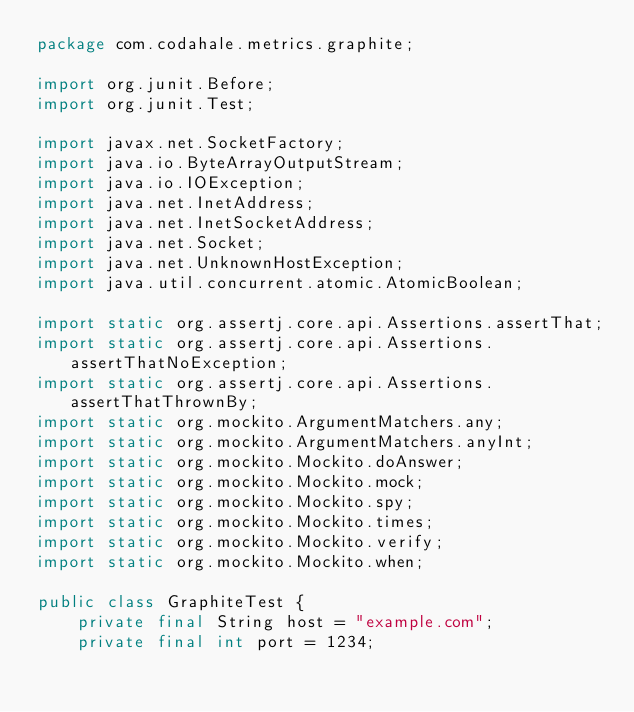<code> <loc_0><loc_0><loc_500><loc_500><_Java_>package com.codahale.metrics.graphite;

import org.junit.Before;
import org.junit.Test;

import javax.net.SocketFactory;
import java.io.ByteArrayOutputStream;
import java.io.IOException;
import java.net.InetAddress;
import java.net.InetSocketAddress;
import java.net.Socket;
import java.net.UnknownHostException;
import java.util.concurrent.atomic.AtomicBoolean;

import static org.assertj.core.api.Assertions.assertThat;
import static org.assertj.core.api.Assertions.assertThatNoException;
import static org.assertj.core.api.Assertions.assertThatThrownBy;
import static org.mockito.ArgumentMatchers.any;
import static org.mockito.ArgumentMatchers.anyInt;
import static org.mockito.Mockito.doAnswer;
import static org.mockito.Mockito.mock;
import static org.mockito.Mockito.spy;
import static org.mockito.Mockito.times;
import static org.mockito.Mockito.verify;
import static org.mockito.Mockito.when;

public class GraphiteTest {
    private final String host = "example.com";
    private final int port = 1234;</code> 